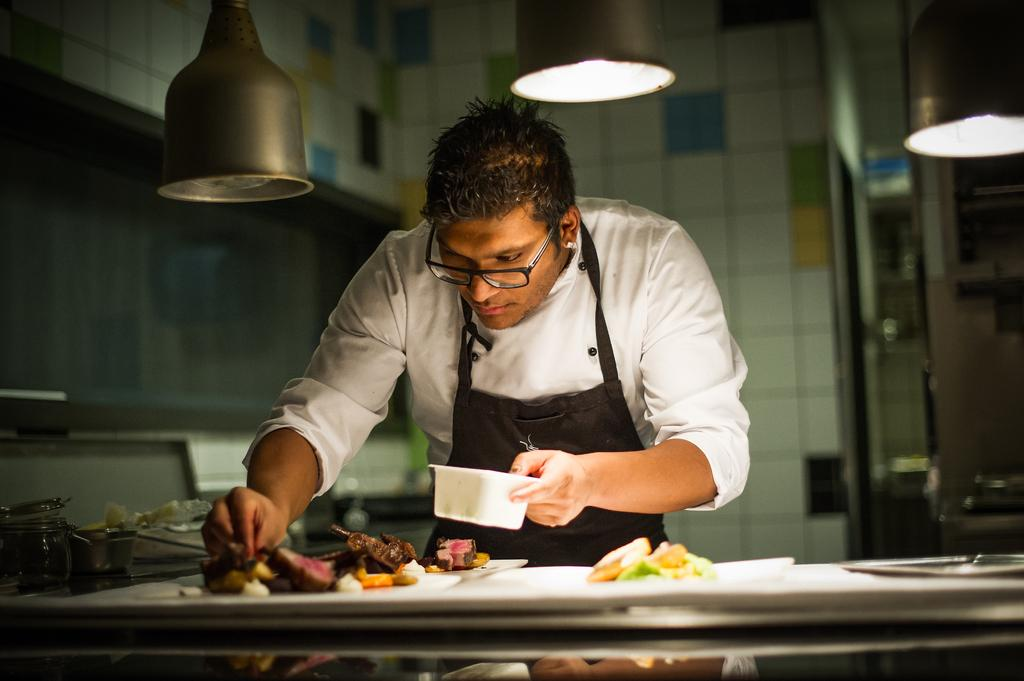What is the man in the image doing? The man is standing in the image and holding a bowl. What else can be seen in the man's hands besides the bowl? There are no other items visible in the man's hands besides the bowl. What objects are present on the table in the image? There are plates and other objects visible on the table in the image. What type of food is present in the image? There is food present in the image, but the specific type of food is not mentioned in the facts. What can be seen in the background of the image? There is a wall and a rod visible in the background of the image. What type of hose is being used to water the plants in the image? There are no plants or hoses present in the image. How many thumbs does the man have in the image? The number of thumbs the man has is not visible or mentioned in the image. 